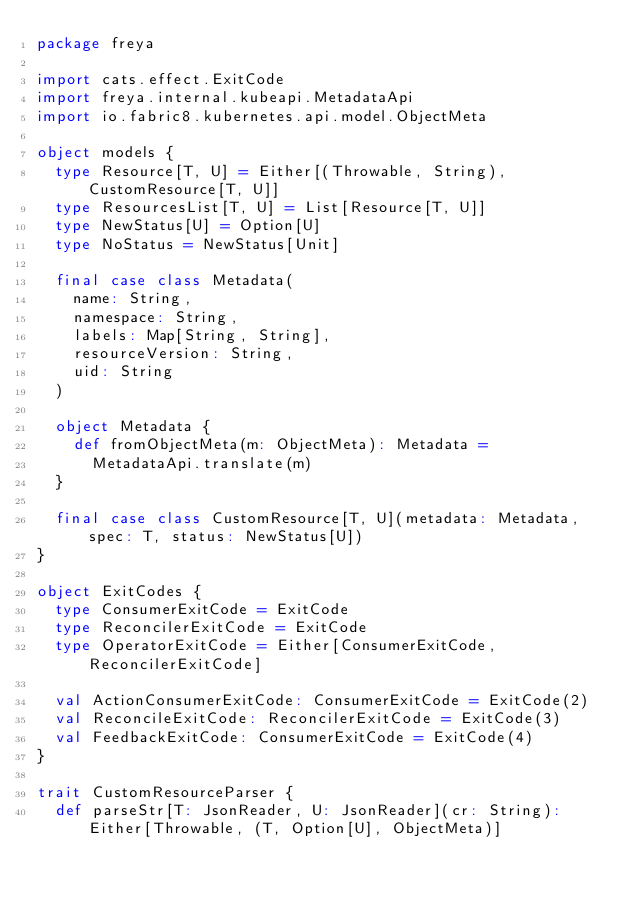<code> <loc_0><loc_0><loc_500><loc_500><_Scala_>package freya

import cats.effect.ExitCode
import freya.internal.kubeapi.MetadataApi
import io.fabric8.kubernetes.api.model.ObjectMeta

object models {
  type Resource[T, U] = Either[(Throwable, String), CustomResource[T, U]]
  type ResourcesList[T, U] = List[Resource[T, U]]
  type NewStatus[U] = Option[U]
  type NoStatus = NewStatus[Unit]

  final case class Metadata(
    name: String,
    namespace: String,
    labels: Map[String, String],
    resourceVersion: String,
    uid: String
  )

  object Metadata {
    def fromObjectMeta(m: ObjectMeta): Metadata =
      MetadataApi.translate(m)
  }

  final case class CustomResource[T, U](metadata: Metadata, spec: T, status: NewStatus[U])
}

object ExitCodes {
  type ConsumerExitCode = ExitCode
  type ReconcilerExitCode = ExitCode
  type OperatorExitCode = Either[ConsumerExitCode, ReconcilerExitCode]

  val ActionConsumerExitCode: ConsumerExitCode = ExitCode(2)
  val ReconcileExitCode: ReconcilerExitCode = ExitCode(3)
  val FeedbackExitCode: ConsumerExitCode = ExitCode(4)
}

trait CustomResourceParser {
  def parseStr[T: JsonReader, U: JsonReader](cr: String): Either[Throwable, (T, Option[U], ObjectMeta)]</code> 